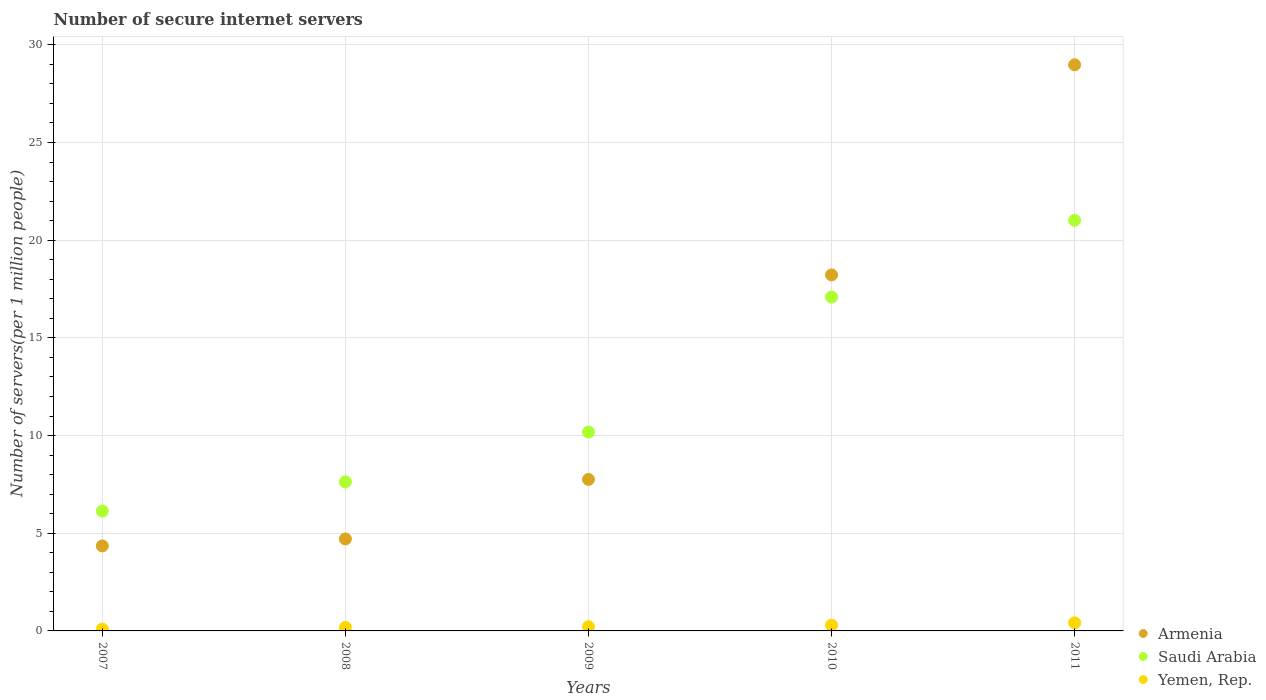How many different coloured dotlines are there?
Give a very brief answer. 3. What is the number of secure internet servers in Saudi Arabia in 2008?
Provide a succinct answer. 7.63. Across all years, what is the maximum number of secure internet servers in Yemen, Rep.?
Your response must be concise. 0.41. Across all years, what is the minimum number of secure internet servers in Saudi Arabia?
Give a very brief answer. 6.13. In which year was the number of secure internet servers in Yemen, Rep. maximum?
Ensure brevity in your answer.  2011. What is the total number of secure internet servers in Saudi Arabia in the graph?
Keep it short and to the point. 62.04. What is the difference between the number of secure internet servers in Saudi Arabia in 2007 and that in 2010?
Offer a terse response. -10.95. What is the difference between the number of secure internet servers in Yemen, Rep. in 2007 and the number of secure internet servers in Saudi Arabia in 2010?
Your answer should be compact. -17. What is the average number of secure internet servers in Saudi Arabia per year?
Your response must be concise. 12.41. In the year 2011, what is the difference between the number of secure internet servers in Saudi Arabia and number of secure internet servers in Armenia?
Offer a very short reply. -7.96. In how many years, is the number of secure internet servers in Armenia greater than 11?
Your answer should be compact. 2. What is the ratio of the number of secure internet servers in Yemen, Rep. in 2009 to that in 2011?
Keep it short and to the point. 0.53. What is the difference between the highest and the second highest number of secure internet servers in Saudi Arabia?
Provide a short and direct response. 3.93. What is the difference between the highest and the lowest number of secure internet servers in Yemen, Rep.?
Offer a very short reply. 0.32. In how many years, is the number of secure internet servers in Armenia greater than the average number of secure internet servers in Armenia taken over all years?
Your answer should be very brief. 2. Is it the case that in every year, the sum of the number of secure internet servers in Yemen, Rep. and number of secure internet servers in Saudi Arabia  is greater than the number of secure internet servers in Armenia?
Offer a very short reply. No. How many dotlines are there?
Keep it short and to the point. 3. How many years are there in the graph?
Offer a terse response. 5. What is the difference between two consecutive major ticks on the Y-axis?
Offer a terse response. 5. Does the graph contain any zero values?
Make the answer very short. No. How are the legend labels stacked?
Your response must be concise. Vertical. What is the title of the graph?
Provide a short and direct response. Number of secure internet servers. Does "High income" appear as one of the legend labels in the graph?
Your answer should be very brief. No. What is the label or title of the Y-axis?
Make the answer very short. Number of servers(per 1 million people). What is the Number of servers(per 1 million people) of Armenia in 2007?
Give a very brief answer. 4.35. What is the Number of servers(per 1 million people) in Saudi Arabia in 2007?
Your answer should be very brief. 6.13. What is the Number of servers(per 1 million people) in Yemen, Rep. in 2007?
Provide a succinct answer. 0.09. What is the Number of servers(per 1 million people) in Armenia in 2008?
Give a very brief answer. 4.71. What is the Number of servers(per 1 million people) in Saudi Arabia in 2008?
Keep it short and to the point. 7.63. What is the Number of servers(per 1 million people) in Yemen, Rep. in 2008?
Offer a terse response. 0.18. What is the Number of servers(per 1 million people) in Armenia in 2009?
Make the answer very short. 7.75. What is the Number of servers(per 1 million people) of Saudi Arabia in 2009?
Make the answer very short. 10.18. What is the Number of servers(per 1 million people) of Yemen, Rep. in 2009?
Offer a terse response. 0.22. What is the Number of servers(per 1 million people) of Armenia in 2010?
Keep it short and to the point. 18.22. What is the Number of servers(per 1 million people) of Saudi Arabia in 2010?
Offer a very short reply. 17.09. What is the Number of servers(per 1 million people) in Yemen, Rep. in 2010?
Your answer should be compact. 0.3. What is the Number of servers(per 1 million people) of Armenia in 2011?
Your response must be concise. 28.98. What is the Number of servers(per 1 million people) of Saudi Arabia in 2011?
Offer a terse response. 21.02. What is the Number of servers(per 1 million people) of Yemen, Rep. in 2011?
Ensure brevity in your answer.  0.41. Across all years, what is the maximum Number of servers(per 1 million people) of Armenia?
Provide a succinct answer. 28.98. Across all years, what is the maximum Number of servers(per 1 million people) in Saudi Arabia?
Keep it short and to the point. 21.02. Across all years, what is the maximum Number of servers(per 1 million people) of Yemen, Rep.?
Your answer should be very brief. 0.41. Across all years, what is the minimum Number of servers(per 1 million people) of Armenia?
Give a very brief answer. 4.35. Across all years, what is the minimum Number of servers(per 1 million people) of Saudi Arabia?
Your answer should be very brief. 6.13. Across all years, what is the minimum Number of servers(per 1 million people) of Yemen, Rep.?
Provide a succinct answer. 0.09. What is the total Number of servers(per 1 million people) in Armenia in the graph?
Your answer should be compact. 64.01. What is the total Number of servers(per 1 million people) in Saudi Arabia in the graph?
Make the answer very short. 62.04. What is the total Number of servers(per 1 million people) in Yemen, Rep. in the graph?
Offer a very short reply. 1.2. What is the difference between the Number of servers(per 1 million people) of Armenia in 2007 and that in 2008?
Provide a short and direct response. -0.36. What is the difference between the Number of servers(per 1 million people) in Saudi Arabia in 2007 and that in 2008?
Provide a succinct answer. -1.49. What is the difference between the Number of servers(per 1 million people) in Yemen, Rep. in 2007 and that in 2008?
Your response must be concise. -0.09. What is the difference between the Number of servers(per 1 million people) in Armenia in 2007 and that in 2009?
Provide a succinct answer. -3.4. What is the difference between the Number of servers(per 1 million people) in Saudi Arabia in 2007 and that in 2009?
Ensure brevity in your answer.  -4.04. What is the difference between the Number of servers(per 1 million people) in Yemen, Rep. in 2007 and that in 2009?
Offer a terse response. -0.13. What is the difference between the Number of servers(per 1 million people) in Armenia in 2007 and that in 2010?
Your answer should be compact. -13.87. What is the difference between the Number of servers(per 1 million people) in Saudi Arabia in 2007 and that in 2010?
Ensure brevity in your answer.  -10.95. What is the difference between the Number of servers(per 1 million people) of Yemen, Rep. in 2007 and that in 2010?
Your answer should be very brief. -0.2. What is the difference between the Number of servers(per 1 million people) of Armenia in 2007 and that in 2011?
Provide a short and direct response. -24.63. What is the difference between the Number of servers(per 1 million people) in Saudi Arabia in 2007 and that in 2011?
Your answer should be very brief. -14.88. What is the difference between the Number of servers(per 1 million people) in Yemen, Rep. in 2007 and that in 2011?
Offer a very short reply. -0.32. What is the difference between the Number of servers(per 1 million people) in Armenia in 2008 and that in 2009?
Your response must be concise. -3.05. What is the difference between the Number of servers(per 1 million people) in Saudi Arabia in 2008 and that in 2009?
Your answer should be very brief. -2.55. What is the difference between the Number of servers(per 1 million people) in Yemen, Rep. in 2008 and that in 2009?
Your answer should be compact. -0.04. What is the difference between the Number of servers(per 1 million people) in Armenia in 2008 and that in 2010?
Offer a very short reply. -13.52. What is the difference between the Number of servers(per 1 million people) of Saudi Arabia in 2008 and that in 2010?
Offer a very short reply. -9.46. What is the difference between the Number of servers(per 1 million people) of Yemen, Rep. in 2008 and that in 2010?
Provide a succinct answer. -0.12. What is the difference between the Number of servers(per 1 million people) of Armenia in 2008 and that in 2011?
Offer a very short reply. -24.27. What is the difference between the Number of servers(per 1 million people) of Saudi Arabia in 2008 and that in 2011?
Ensure brevity in your answer.  -13.39. What is the difference between the Number of servers(per 1 million people) of Yemen, Rep. in 2008 and that in 2011?
Your answer should be compact. -0.23. What is the difference between the Number of servers(per 1 million people) of Armenia in 2009 and that in 2010?
Your response must be concise. -10.47. What is the difference between the Number of servers(per 1 million people) in Saudi Arabia in 2009 and that in 2010?
Give a very brief answer. -6.91. What is the difference between the Number of servers(per 1 million people) in Yemen, Rep. in 2009 and that in 2010?
Provide a succinct answer. -0.08. What is the difference between the Number of servers(per 1 million people) in Armenia in 2009 and that in 2011?
Make the answer very short. -21.22. What is the difference between the Number of servers(per 1 million people) of Saudi Arabia in 2009 and that in 2011?
Offer a very short reply. -10.84. What is the difference between the Number of servers(per 1 million people) of Yemen, Rep. in 2009 and that in 2011?
Offer a very short reply. -0.19. What is the difference between the Number of servers(per 1 million people) in Armenia in 2010 and that in 2011?
Offer a very short reply. -10.75. What is the difference between the Number of servers(per 1 million people) in Saudi Arabia in 2010 and that in 2011?
Offer a terse response. -3.93. What is the difference between the Number of servers(per 1 million people) in Yemen, Rep. in 2010 and that in 2011?
Ensure brevity in your answer.  -0.12. What is the difference between the Number of servers(per 1 million people) of Armenia in 2007 and the Number of servers(per 1 million people) of Saudi Arabia in 2008?
Offer a very short reply. -3.28. What is the difference between the Number of servers(per 1 million people) in Armenia in 2007 and the Number of servers(per 1 million people) in Yemen, Rep. in 2008?
Provide a short and direct response. 4.17. What is the difference between the Number of servers(per 1 million people) in Saudi Arabia in 2007 and the Number of servers(per 1 million people) in Yemen, Rep. in 2008?
Provide a succinct answer. 5.96. What is the difference between the Number of servers(per 1 million people) of Armenia in 2007 and the Number of servers(per 1 million people) of Saudi Arabia in 2009?
Give a very brief answer. -5.83. What is the difference between the Number of servers(per 1 million people) in Armenia in 2007 and the Number of servers(per 1 million people) in Yemen, Rep. in 2009?
Ensure brevity in your answer.  4.13. What is the difference between the Number of servers(per 1 million people) in Saudi Arabia in 2007 and the Number of servers(per 1 million people) in Yemen, Rep. in 2009?
Offer a terse response. 5.92. What is the difference between the Number of servers(per 1 million people) in Armenia in 2007 and the Number of servers(per 1 million people) in Saudi Arabia in 2010?
Provide a succinct answer. -12.74. What is the difference between the Number of servers(per 1 million people) of Armenia in 2007 and the Number of servers(per 1 million people) of Yemen, Rep. in 2010?
Ensure brevity in your answer.  4.05. What is the difference between the Number of servers(per 1 million people) of Saudi Arabia in 2007 and the Number of servers(per 1 million people) of Yemen, Rep. in 2010?
Give a very brief answer. 5.84. What is the difference between the Number of servers(per 1 million people) in Armenia in 2007 and the Number of servers(per 1 million people) in Saudi Arabia in 2011?
Offer a terse response. -16.66. What is the difference between the Number of servers(per 1 million people) in Armenia in 2007 and the Number of servers(per 1 million people) in Yemen, Rep. in 2011?
Provide a short and direct response. 3.94. What is the difference between the Number of servers(per 1 million people) in Saudi Arabia in 2007 and the Number of servers(per 1 million people) in Yemen, Rep. in 2011?
Make the answer very short. 5.72. What is the difference between the Number of servers(per 1 million people) of Armenia in 2008 and the Number of servers(per 1 million people) of Saudi Arabia in 2009?
Offer a terse response. -5.47. What is the difference between the Number of servers(per 1 million people) of Armenia in 2008 and the Number of servers(per 1 million people) of Yemen, Rep. in 2009?
Make the answer very short. 4.49. What is the difference between the Number of servers(per 1 million people) in Saudi Arabia in 2008 and the Number of servers(per 1 million people) in Yemen, Rep. in 2009?
Your response must be concise. 7.41. What is the difference between the Number of servers(per 1 million people) in Armenia in 2008 and the Number of servers(per 1 million people) in Saudi Arabia in 2010?
Provide a short and direct response. -12.38. What is the difference between the Number of servers(per 1 million people) in Armenia in 2008 and the Number of servers(per 1 million people) in Yemen, Rep. in 2010?
Ensure brevity in your answer.  4.41. What is the difference between the Number of servers(per 1 million people) of Saudi Arabia in 2008 and the Number of servers(per 1 million people) of Yemen, Rep. in 2010?
Give a very brief answer. 7.33. What is the difference between the Number of servers(per 1 million people) of Armenia in 2008 and the Number of servers(per 1 million people) of Saudi Arabia in 2011?
Your response must be concise. -16.31. What is the difference between the Number of servers(per 1 million people) of Armenia in 2008 and the Number of servers(per 1 million people) of Yemen, Rep. in 2011?
Offer a very short reply. 4.29. What is the difference between the Number of servers(per 1 million people) in Saudi Arabia in 2008 and the Number of servers(per 1 million people) in Yemen, Rep. in 2011?
Your answer should be very brief. 7.22. What is the difference between the Number of servers(per 1 million people) of Armenia in 2009 and the Number of servers(per 1 million people) of Saudi Arabia in 2010?
Ensure brevity in your answer.  -9.33. What is the difference between the Number of servers(per 1 million people) of Armenia in 2009 and the Number of servers(per 1 million people) of Yemen, Rep. in 2010?
Ensure brevity in your answer.  7.46. What is the difference between the Number of servers(per 1 million people) in Saudi Arabia in 2009 and the Number of servers(per 1 million people) in Yemen, Rep. in 2010?
Keep it short and to the point. 9.88. What is the difference between the Number of servers(per 1 million people) in Armenia in 2009 and the Number of servers(per 1 million people) in Saudi Arabia in 2011?
Provide a succinct answer. -13.26. What is the difference between the Number of servers(per 1 million people) of Armenia in 2009 and the Number of servers(per 1 million people) of Yemen, Rep. in 2011?
Offer a very short reply. 7.34. What is the difference between the Number of servers(per 1 million people) in Saudi Arabia in 2009 and the Number of servers(per 1 million people) in Yemen, Rep. in 2011?
Your answer should be compact. 9.77. What is the difference between the Number of servers(per 1 million people) in Armenia in 2010 and the Number of servers(per 1 million people) in Saudi Arabia in 2011?
Give a very brief answer. -2.79. What is the difference between the Number of servers(per 1 million people) in Armenia in 2010 and the Number of servers(per 1 million people) in Yemen, Rep. in 2011?
Offer a very short reply. 17.81. What is the difference between the Number of servers(per 1 million people) in Saudi Arabia in 2010 and the Number of servers(per 1 million people) in Yemen, Rep. in 2011?
Keep it short and to the point. 16.67. What is the average Number of servers(per 1 million people) in Armenia per year?
Offer a terse response. 12.8. What is the average Number of servers(per 1 million people) of Saudi Arabia per year?
Your answer should be very brief. 12.41. What is the average Number of servers(per 1 million people) in Yemen, Rep. per year?
Give a very brief answer. 0.24. In the year 2007, what is the difference between the Number of servers(per 1 million people) of Armenia and Number of servers(per 1 million people) of Saudi Arabia?
Make the answer very short. -1.78. In the year 2007, what is the difference between the Number of servers(per 1 million people) in Armenia and Number of servers(per 1 million people) in Yemen, Rep.?
Give a very brief answer. 4.26. In the year 2007, what is the difference between the Number of servers(per 1 million people) in Saudi Arabia and Number of servers(per 1 million people) in Yemen, Rep.?
Offer a very short reply. 6.04. In the year 2008, what is the difference between the Number of servers(per 1 million people) in Armenia and Number of servers(per 1 million people) in Saudi Arabia?
Your answer should be very brief. -2.92. In the year 2008, what is the difference between the Number of servers(per 1 million people) in Armenia and Number of servers(per 1 million people) in Yemen, Rep.?
Your answer should be very brief. 4.53. In the year 2008, what is the difference between the Number of servers(per 1 million people) in Saudi Arabia and Number of servers(per 1 million people) in Yemen, Rep.?
Ensure brevity in your answer.  7.45. In the year 2009, what is the difference between the Number of servers(per 1 million people) in Armenia and Number of servers(per 1 million people) in Saudi Arabia?
Give a very brief answer. -2.42. In the year 2009, what is the difference between the Number of servers(per 1 million people) in Armenia and Number of servers(per 1 million people) in Yemen, Rep.?
Your answer should be compact. 7.54. In the year 2009, what is the difference between the Number of servers(per 1 million people) of Saudi Arabia and Number of servers(per 1 million people) of Yemen, Rep.?
Offer a very short reply. 9.96. In the year 2010, what is the difference between the Number of servers(per 1 million people) of Armenia and Number of servers(per 1 million people) of Saudi Arabia?
Provide a succinct answer. 1.13. In the year 2010, what is the difference between the Number of servers(per 1 million people) in Armenia and Number of servers(per 1 million people) in Yemen, Rep.?
Keep it short and to the point. 17.93. In the year 2010, what is the difference between the Number of servers(per 1 million people) in Saudi Arabia and Number of servers(per 1 million people) in Yemen, Rep.?
Offer a very short reply. 16.79. In the year 2011, what is the difference between the Number of servers(per 1 million people) of Armenia and Number of servers(per 1 million people) of Saudi Arabia?
Offer a terse response. 7.96. In the year 2011, what is the difference between the Number of servers(per 1 million people) in Armenia and Number of servers(per 1 million people) in Yemen, Rep.?
Offer a terse response. 28.56. In the year 2011, what is the difference between the Number of servers(per 1 million people) in Saudi Arabia and Number of servers(per 1 million people) in Yemen, Rep.?
Offer a terse response. 20.6. What is the ratio of the Number of servers(per 1 million people) of Armenia in 2007 to that in 2008?
Your answer should be compact. 0.92. What is the ratio of the Number of servers(per 1 million people) in Saudi Arabia in 2007 to that in 2008?
Your answer should be very brief. 0.8. What is the ratio of the Number of servers(per 1 million people) of Yemen, Rep. in 2007 to that in 2008?
Your answer should be very brief. 0.51. What is the ratio of the Number of servers(per 1 million people) in Armenia in 2007 to that in 2009?
Provide a succinct answer. 0.56. What is the ratio of the Number of servers(per 1 million people) of Saudi Arabia in 2007 to that in 2009?
Ensure brevity in your answer.  0.6. What is the ratio of the Number of servers(per 1 million people) in Yemen, Rep. in 2007 to that in 2009?
Your answer should be very brief. 0.42. What is the ratio of the Number of servers(per 1 million people) in Armenia in 2007 to that in 2010?
Make the answer very short. 0.24. What is the ratio of the Number of servers(per 1 million people) in Saudi Arabia in 2007 to that in 2010?
Give a very brief answer. 0.36. What is the ratio of the Number of servers(per 1 million people) of Yemen, Rep. in 2007 to that in 2010?
Keep it short and to the point. 0.31. What is the ratio of the Number of servers(per 1 million people) of Armenia in 2007 to that in 2011?
Provide a succinct answer. 0.15. What is the ratio of the Number of servers(per 1 million people) in Saudi Arabia in 2007 to that in 2011?
Your answer should be compact. 0.29. What is the ratio of the Number of servers(per 1 million people) of Yemen, Rep. in 2007 to that in 2011?
Offer a terse response. 0.22. What is the ratio of the Number of servers(per 1 million people) in Armenia in 2008 to that in 2009?
Your answer should be compact. 0.61. What is the ratio of the Number of servers(per 1 million people) in Saudi Arabia in 2008 to that in 2009?
Make the answer very short. 0.75. What is the ratio of the Number of servers(per 1 million people) in Yemen, Rep. in 2008 to that in 2009?
Provide a succinct answer. 0.82. What is the ratio of the Number of servers(per 1 million people) in Armenia in 2008 to that in 2010?
Ensure brevity in your answer.  0.26. What is the ratio of the Number of servers(per 1 million people) in Saudi Arabia in 2008 to that in 2010?
Provide a succinct answer. 0.45. What is the ratio of the Number of servers(per 1 million people) of Yemen, Rep. in 2008 to that in 2010?
Keep it short and to the point. 0.6. What is the ratio of the Number of servers(per 1 million people) of Armenia in 2008 to that in 2011?
Ensure brevity in your answer.  0.16. What is the ratio of the Number of servers(per 1 million people) of Saudi Arabia in 2008 to that in 2011?
Offer a very short reply. 0.36. What is the ratio of the Number of servers(per 1 million people) in Yemen, Rep. in 2008 to that in 2011?
Keep it short and to the point. 0.43. What is the ratio of the Number of servers(per 1 million people) of Armenia in 2009 to that in 2010?
Your response must be concise. 0.43. What is the ratio of the Number of servers(per 1 million people) of Saudi Arabia in 2009 to that in 2010?
Your answer should be compact. 0.6. What is the ratio of the Number of servers(per 1 million people) of Yemen, Rep. in 2009 to that in 2010?
Offer a very short reply. 0.73. What is the ratio of the Number of servers(per 1 million people) of Armenia in 2009 to that in 2011?
Ensure brevity in your answer.  0.27. What is the ratio of the Number of servers(per 1 million people) in Saudi Arabia in 2009 to that in 2011?
Offer a very short reply. 0.48. What is the ratio of the Number of servers(per 1 million people) of Yemen, Rep. in 2009 to that in 2011?
Provide a short and direct response. 0.53. What is the ratio of the Number of servers(per 1 million people) in Armenia in 2010 to that in 2011?
Keep it short and to the point. 0.63. What is the ratio of the Number of servers(per 1 million people) of Saudi Arabia in 2010 to that in 2011?
Keep it short and to the point. 0.81. What is the ratio of the Number of servers(per 1 million people) of Yemen, Rep. in 2010 to that in 2011?
Make the answer very short. 0.72. What is the difference between the highest and the second highest Number of servers(per 1 million people) of Armenia?
Provide a succinct answer. 10.75. What is the difference between the highest and the second highest Number of servers(per 1 million people) in Saudi Arabia?
Offer a terse response. 3.93. What is the difference between the highest and the second highest Number of servers(per 1 million people) in Yemen, Rep.?
Keep it short and to the point. 0.12. What is the difference between the highest and the lowest Number of servers(per 1 million people) in Armenia?
Keep it short and to the point. 24.63. What is the difference between the highest and the lowest Number of servers(per 1 million people) in Saudi Arabia?
Offer a terse response. 14.88. What is the difference between the highest and the lowest Number of servers(per 1 million people) in Yemen, Rep.?
Offer a terse response. 0.32. 